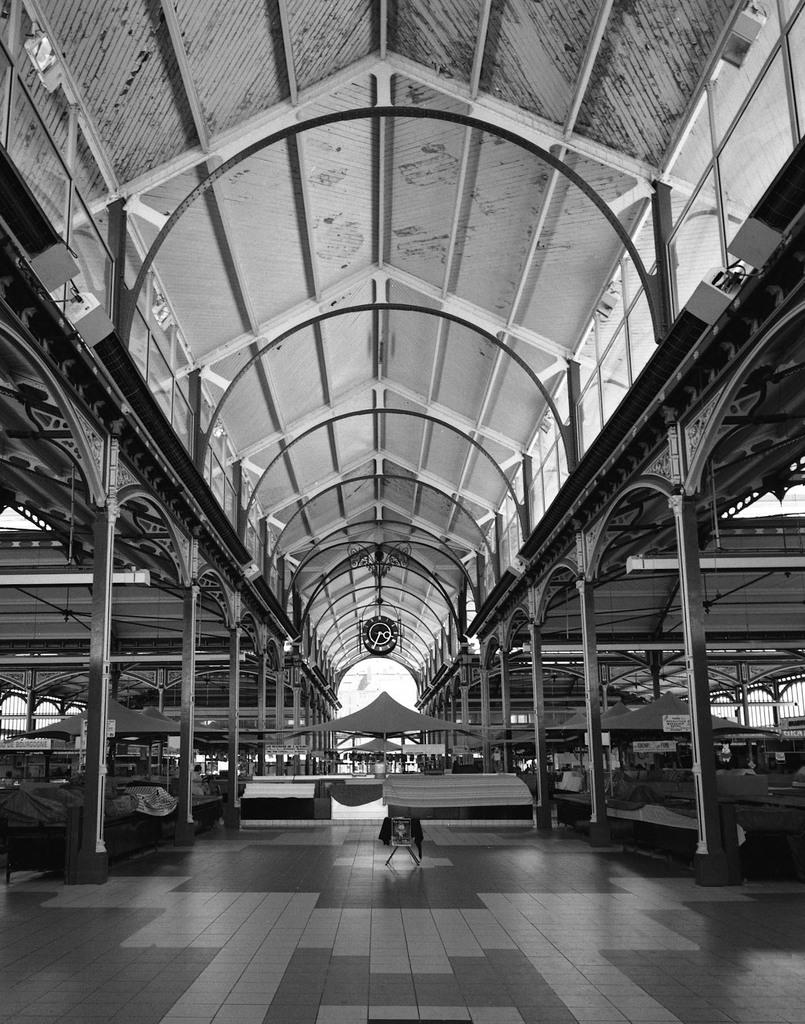What is the color scheme of the image? The image is black and white. What is the main subject of the image? The image shows an inner view of a building. What architectural features can be seen in the building? The building contains pillars. Are there any decorative items in the image? Yes, there is a photo frame in the image. What type of material is used for the grills in the image? Metal grills are present in the image. Is there any indication of time in the image? Yes, there is a clock in the image. What type of temporary shelter is visible in the image? Some tents are visible in the image. What is the uppermost part of the building in the image? There is a roof in the image. What type of winter sport is being played in the image? There is no winter sport or any indication of winter in the image. How does the building twist in the image? The building does not twist in the image; it is a static structure. 